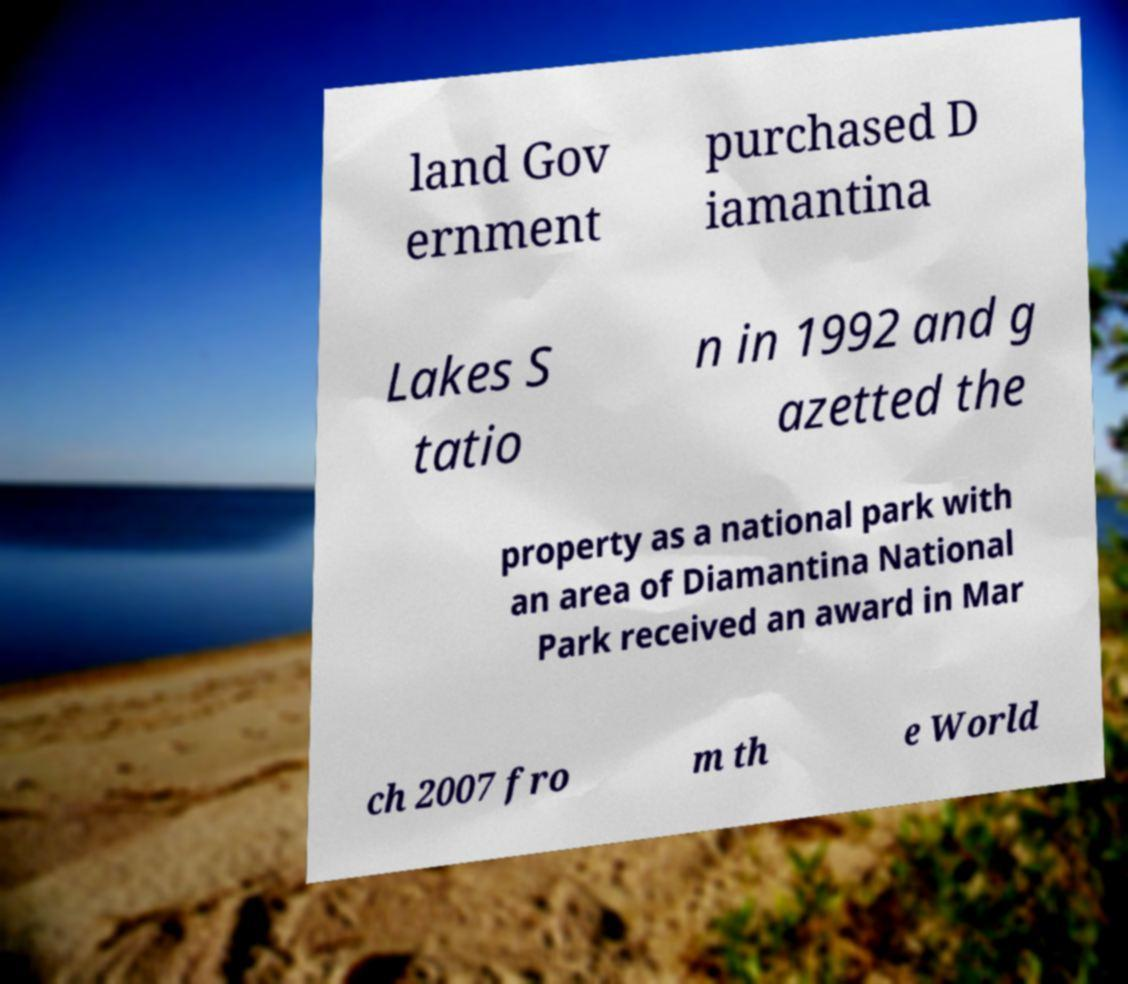For documentation purposes, I need the text within this image transcribed. Could you provide that? land Gov ernment purchased D iamantina Lakes S tatio n in 1992 and g azetted the property as a national park with an area of Diamantina National Park received an award in Mar ch 2007 fro m th e World 